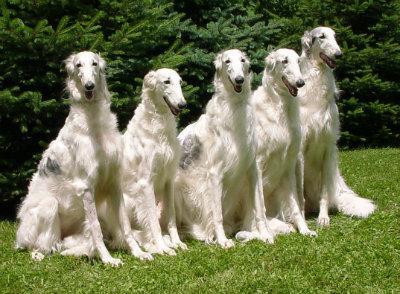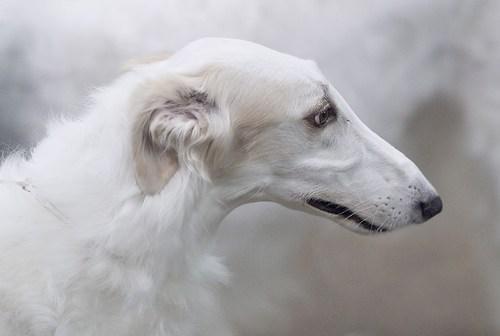The first image is the image on the left, the second image is the image on the right. For the images displayed, is the sentence "There are three hounds on the grass in total." factually correct? Answer yes or no. No. 